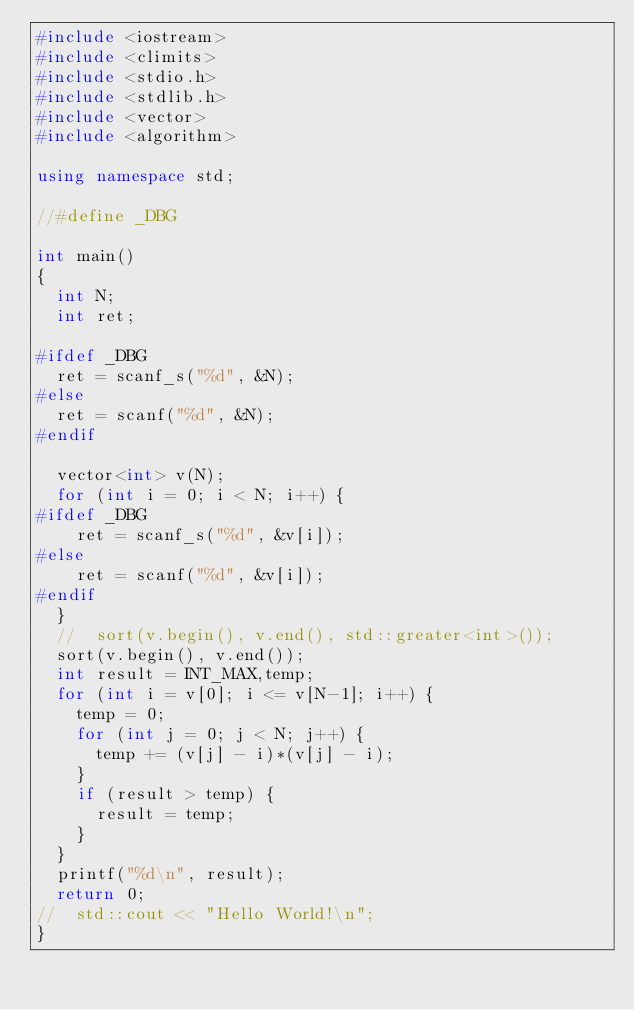Convert code to text. <code><loc_0><loc_0><loc_500><loc_500><_C++_>#include <iostream>
#include <climits>
#include <stdio.h>
#include <stdlib.h>
#include <vector>
#include <algorithm>

using namespace std;

//#define _DBG

int main()
{
	int N;
	int ret;

#ifdef _DBG
	ret = scanf_s("%d", &N);
#else
	ret = scanf("%d", &N);
#endif

	vector<int> v(N);
	for (int i = 0; i < N; i++) {
#ifdef _DBG
		ret = scanf_s("%d", &v[i]);
#else
		ret = scanf("%d", &v[i]);
#endif
	}
	//	sort(v.begin(), v.end(), std::greater<int>());
	sort(v.begin(), v.end());
	int result = INT_MAX,temp;
	for (int i = v[0]; i <= v[N-1]; i++) {
		temp = 0;
		for (int j = 0; j < N; j++) {
			temp += (v[j] - i)*(v[j] - i);
		}
		if (result > temp) {
			result = temp;
		}
	}
	printf("%d\n", result);
	return 0;
//	std::cout << "Hello World!\n"; 
}
</code> 